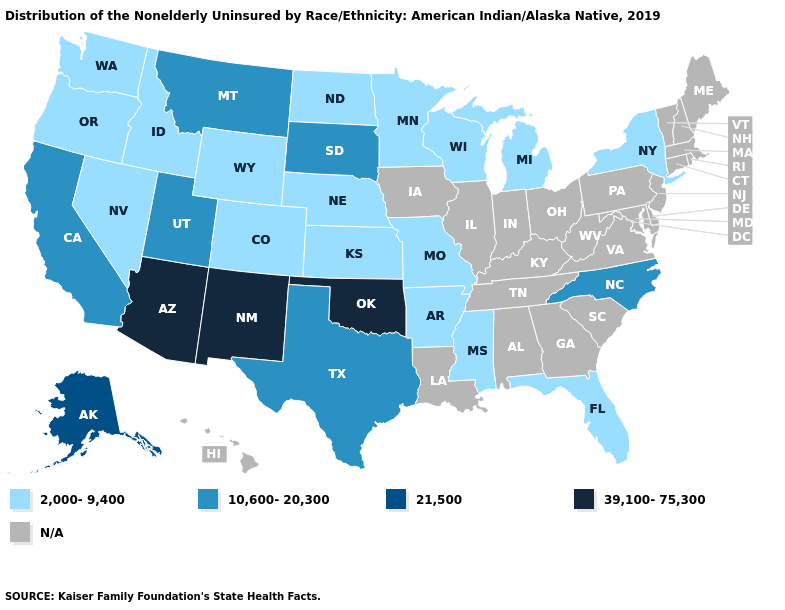What is the highest value in states that border Utah?
Answer briefly. 39,100-75,300. Name the states that have a value in the range 39,100-75,300?
Keep it brief. Arizona, New Mexico, Oklahoma. Name the states that have a value in the range 21,500?
Concise answer only. Alaska. What is the value of Tennessee?
Give a very brief answer. N/A. What is the value of Nevada?
Quick response, please. 2,000-9,400. Does Colorado have the lowest value in the USA?
Give a very brief answer. Yes. Name the states that have a value in the range 39,100-75,300?
Be succinct. Arizona, New Mexico, Oklahoma. What is the highest value in the USA?
Quick response, please. 39,100-75,300. Which states have the lowest value in the USA?
Quick response, please. Arkansas, Colorado, Florida, Idaho, Kansas, Michigan, Minnesota, Mississippi, Missouri, Nebraska, Nevada, New York, North Dakota, Oregon, Washington, Wisconsin, Wyoming. Does the first symbol in the legend represent the smallest category?
Write a very short answer. Yes. What is the lowest value in the USA?
Short answer required. 2,000-9,400. Does Arizona have the highest value in the USA?
Short answer required. Yes. 